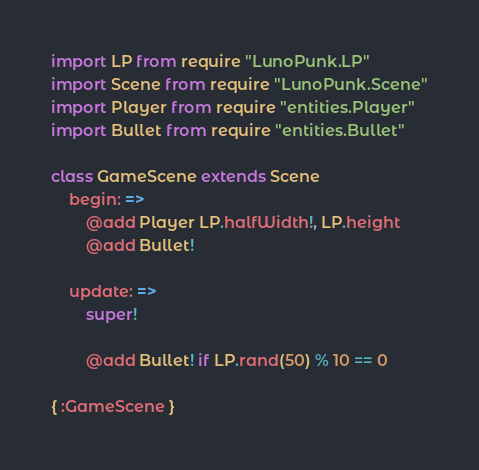<code> <loc_0><loc_0><loc_500><loc_500><_MoonScript_>import LP from require "LunoPunk.LP"
import Scene from require "LunoPunk.Scene"
import Player from require "entities.Player"
import Bullet from require "entities.Bullet"

class GameScene extends Scene
	begin: =>
		@add Player LP.halfWidth!, LP.height
		@add Bullet!

	update: =>
		super!

		@add Bullet! if LP.rand(50) % 10 == 0

{ :GameScene }
</code> 